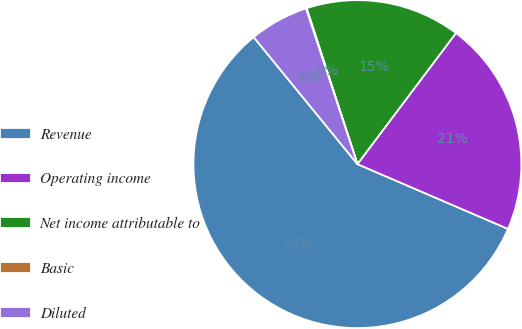<chart> <loc_0><loc_0><loc_500><loc_500><pie_chart><fcel>Revenue<fcel>Operating income<fcel>Net income attributable to<fcel>Basic<fcel>Diluted<nl><fcel>57.63%<fcel>21.21%<fcel>15.27%<fcel>0.07%<fcel>5.82%<nl></chart> 